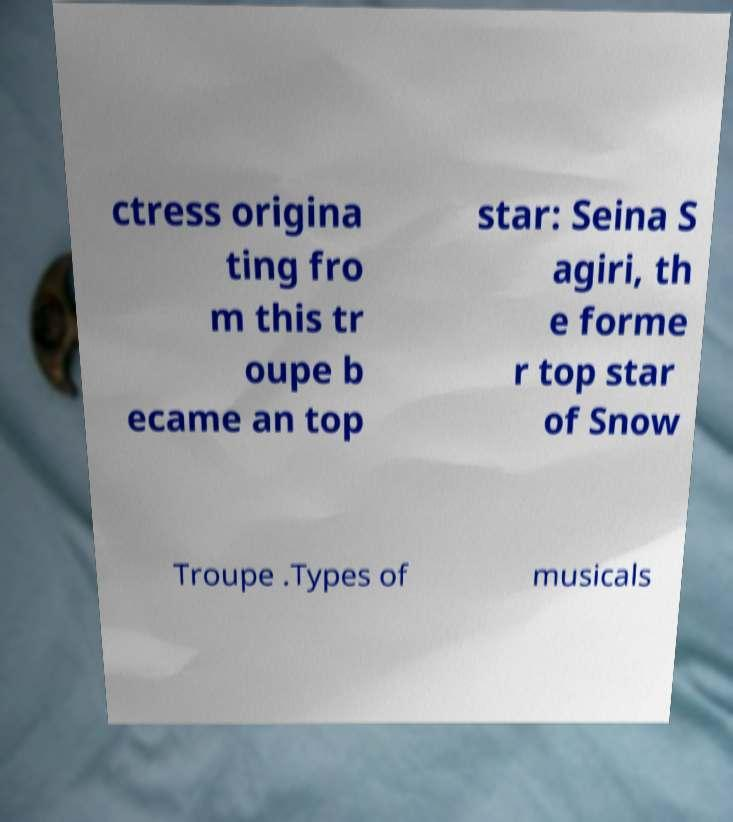I need the written content from this picture converted into text. Can you do that? ctress origina ting fro m this tr oupe b ecame an top star: Seina S agiri, th e forme r top star of Snow Troupe .Types of musicals 